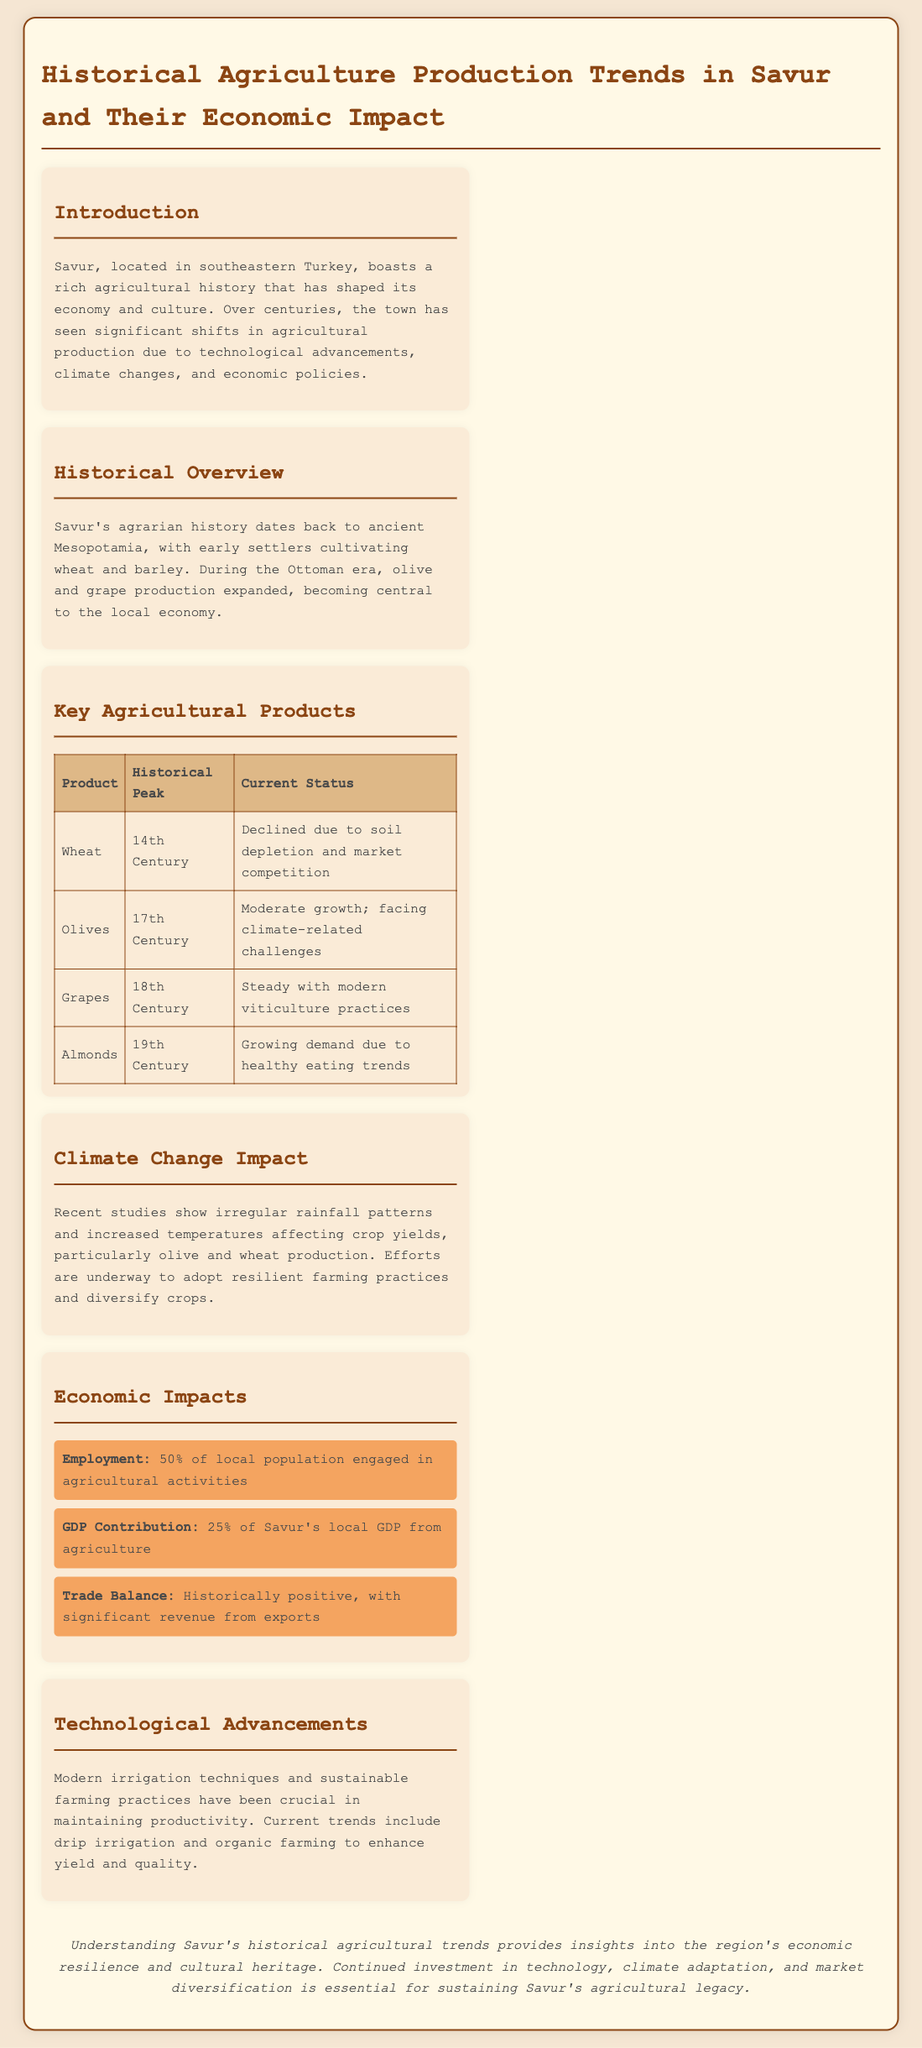What was the historical peak for wheat production? The document states that the historical peak for wheat production occurred in the 14th Century.
Answer: 14th Century What percentage of the local population is engaged in agricultural activities? The agricultural section mentions that 50% of the local population is engaged in agricultural activities.
Answer: 50% What are the current challenges facing olive production? The document notes that olive production is facing climate-related challenges.
Answer: Climate-related challenges In which century did almond demand start to grow? The document indicates that almond demand started to grow in the 19th Century.
Answer: 19th Century What is the GDP contribution of agriculture to Savur's local GDP? According to the economic impacts section, agriculture contributes 25% to Savur's local GDP.
Answer: 25% What modern technique is mentioned for improving irrigation? The document discusses drip irrigation as a modern technique for improving irrigation.
Answer: Drip irrigation Which agricultural product has a steady current status due to modern practices? The document states that grapes have a steady current status due to modern viticulture practices.
Answer: Grapes What was the main agricultural focus during the Ottoman era? The historical overview mentions that olive and grape production expanded during the Ottoman era.
Answer: Olive and grape production What is one of the technological advancements mentioned in the document? The document highlights sustainable farming practices as a technological advancement.
Answer: Sustainable farming practices 